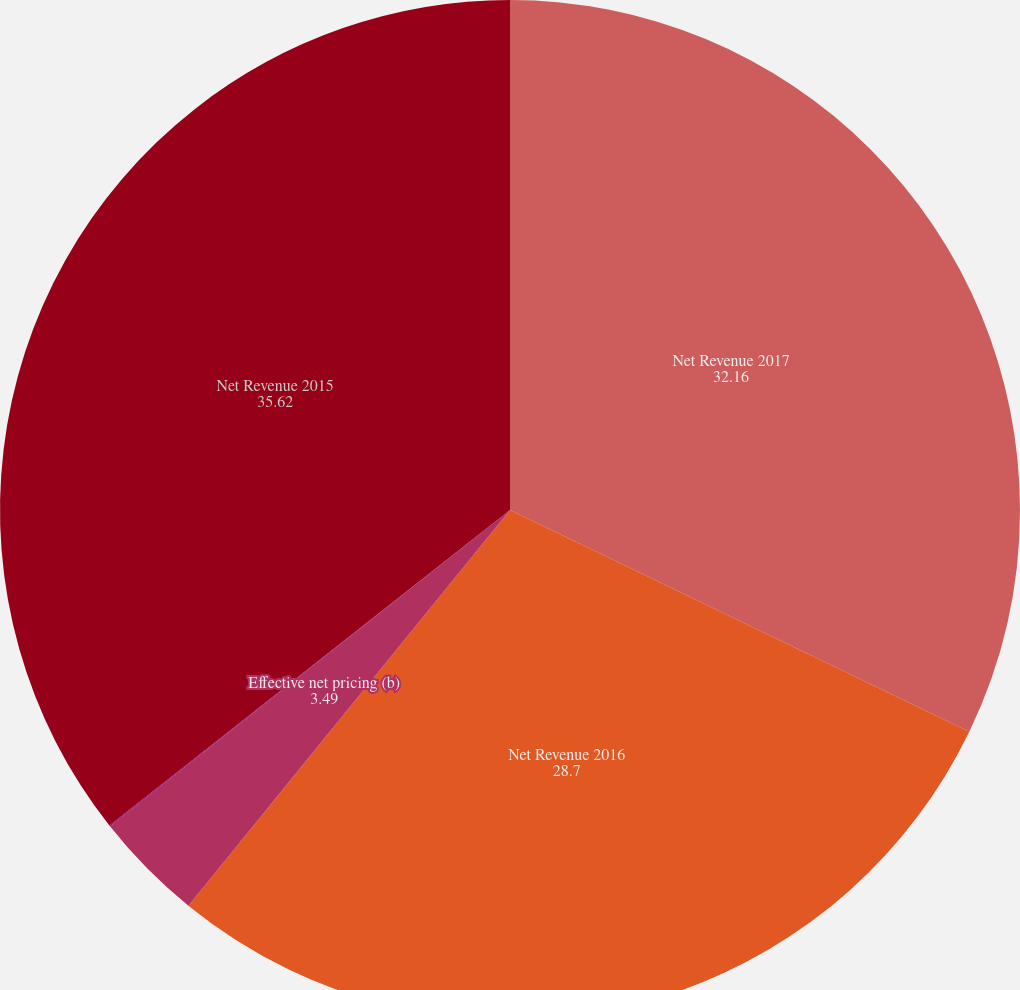Convert chart to OTSL. <chart><loc_0><loc_0><loc_500><loc_500><pie_chart><fcel>Net Revenue 2017<fcel>Net Revenue 2016<fcel>Effective net pricing (b)<fcel>Reported growth (e)<fcel>Net Revenue 2015<nl><fcel>32.16%<fcel>28.7%<fcel>3.49%<fcel>0.03%<fcel>35.62%<nl></chart> 